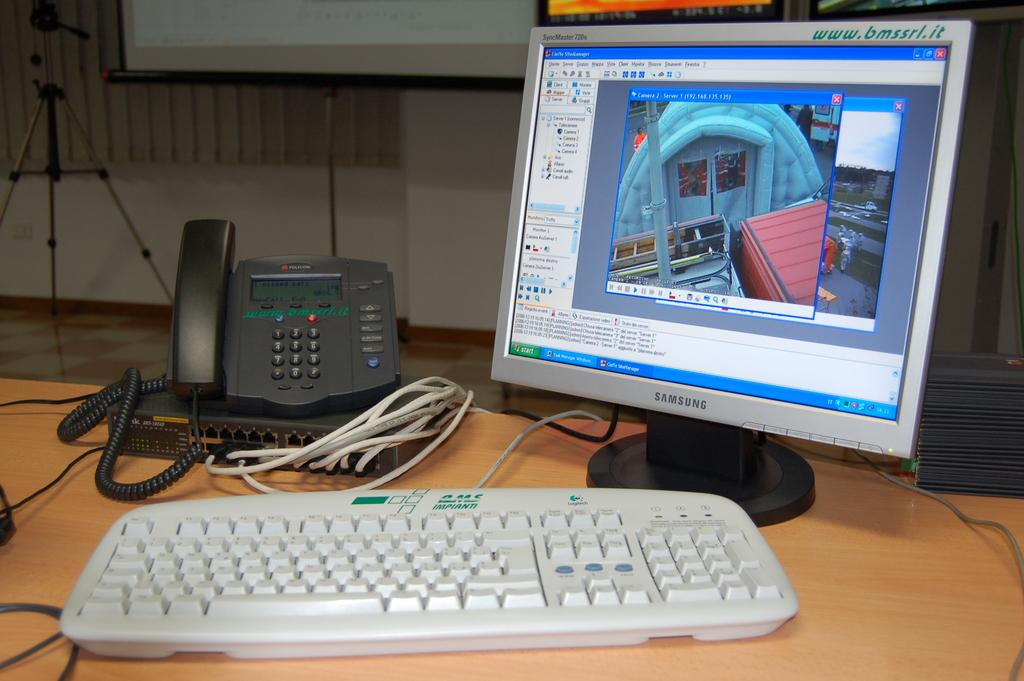What electronic device is visible in the image? There is a monitor in the image. What is used for input with the monitor? There is a keyboard in the image. What communication device is present in the image? There is a telephone in the image. What connects the devices in the image? Cables are visible in the image. What is the unspecified object on the table? The description does not specify the object on the table. What can be seen in the background of the image? There is a stand, a board, frames, and a wall in the background of the image. What type of border is present around the monitor in the image? There is no mention of a border around the monitor in the image. What effect does the presence of the telephone have on the monitor's performance? The provided facts do not mention any relationship between the telephone and the monitor's performance. Is there a man in the image? The provided facts do not mention the presence of a man in the image. 